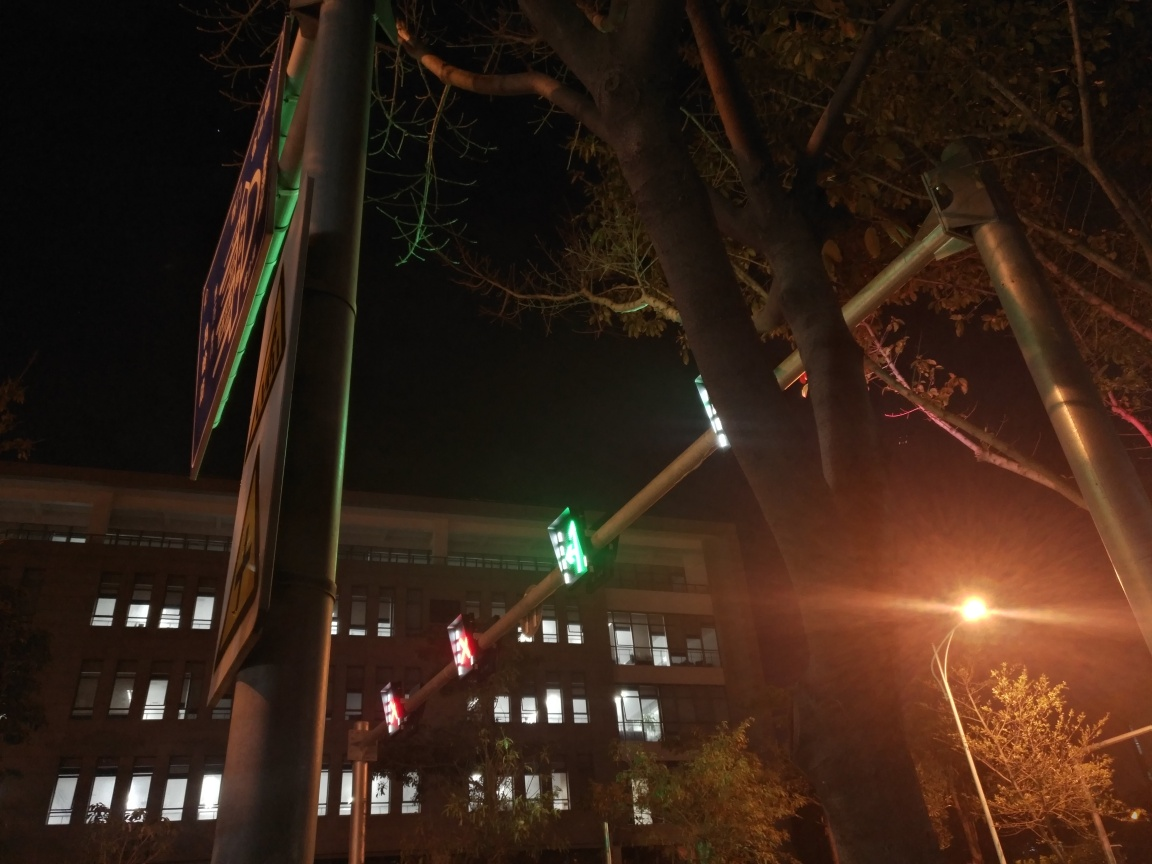Can we make any assumptions about the location based on the signage in the image? It appears to be an urban setting likely in a country where English is used, judging by the street signs. The presence of traffic lights and pedestrian crossing signals suggests it could be near a busy intersection or along a main road in the city. 